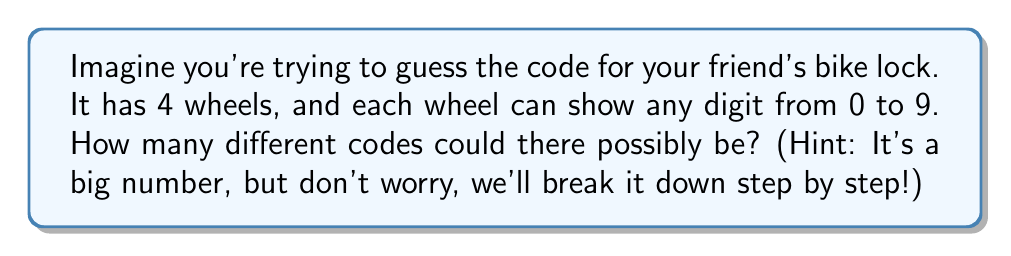Can you answer this question? Okay, let's think about this step-by-step:

1) First, let's look at just one wheel. How many choices do we have for that?
   - Each wheel can show any digit from 0 to 9, so that's 10 choices.

2) Now, for the second wheel, we again have 10 choices, regardless of what we picked for the first wheel.

3) The same goes for the third and fourth wheels - 10 choices each.

4) When we have a series of choices like this, where each choice is independent of the others, we multiply the number of possibilities for each choice.

5) So, we can represent this mathematically as:

   $$ 10 \times 10 \times 10 \times 10 $$

6) This is the same as:

   $$ 10^4 $$

7) Now, $10^4$ might look scary, but we can break it down:
   $$ 10^4 = 10 \times 10 \times 10 \times 10 = 10,000 $$

So, there are 10,000 possible combinations for the lock!
Answer: 10,000 